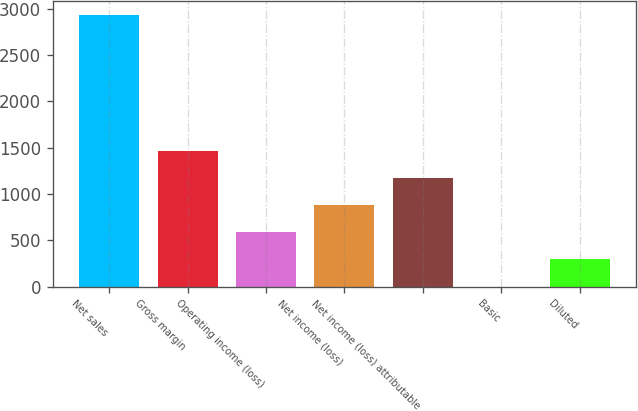Convert chart to OTSL. <chart><loc_0><loc_0><loc_500><loc_500><bar_chart><fcel>Net sales<fcel>Gross margin<fcel>Operating income (loss)<fcel>Net income (loss)<fcel>Net income (loss) attributable<fcel>Basic<fcel>Diluted<nl><fcel>2934<fcel>1467.04<fcel>586.87<fcel>880.26<fcel>1173.65<fcel>0.09<fcel>293.48<nl></chart> 